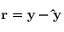<formula> <loc_0><loc_0><loc_500><loc_500>r = y - \hat { y }</formula> 